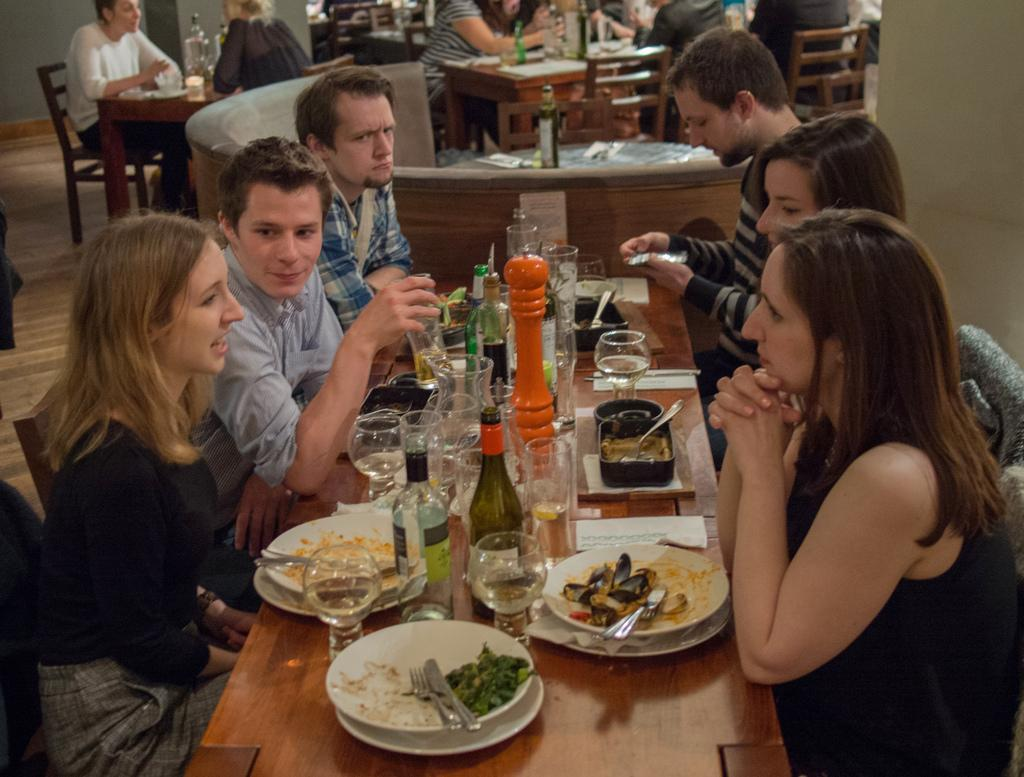What is the state of the room in the image? The room is closed. How many people are present in the room? There are many people in the room. What are the people doing in the room? The people are sitting on chairs. What are the chairs facing in the room? The chairs are in front of tables. What items can be seen on the tables? There are wine bottles, glasses, plates, spoons, and dishes on the tables. What type of idea is being discussed by the people in the image? There is no indication in the image of any ideas being discussed, as the focus is on the people sitting on chairs and the items on the tables. --- Facts: 1. There is a car in the image. 2. The car is red. 3. The car has four wheels. 4. The car has a license plate. 5. The license plate has numbers and letters. 6. The car is parked on the street. 7. There are trees on the street. 8. The sky is visible in the image. Absurd Topics: bird, parachute, ocean Conversation: What is the main subject of the image? The main subject of the image is a car. What color is the car? The car is red. How many wheels does the car have? The car has four wheels. What can be seen on the car's license plate? The license plate has numbers and letters. Where is the car located in the image? The car is parked on the street. What type of vegetation is present on the street? There are trees on the street. What is visible in the background of the image? The sky is visible in the image. Reasoning: Let's think step by step in order to produce the conversation. We start by identifying the main subject of the image, which is the car. Then, we describe specific features of the car, such as its color, number of wheels, and the information on its license plate. Next, we observe the car's location and the surrounding environment, noting the presence of trees and the sky. Each question is designed to elicit a specific detail about the image that is known from the provided facts. Absurd Question/Answer: Can you see a bird flying with a parachute over the ocean in the image? There is no bird, parachute, or ocean present in the image; it features a red car parked on the street with trees and the sky visible in the background. 